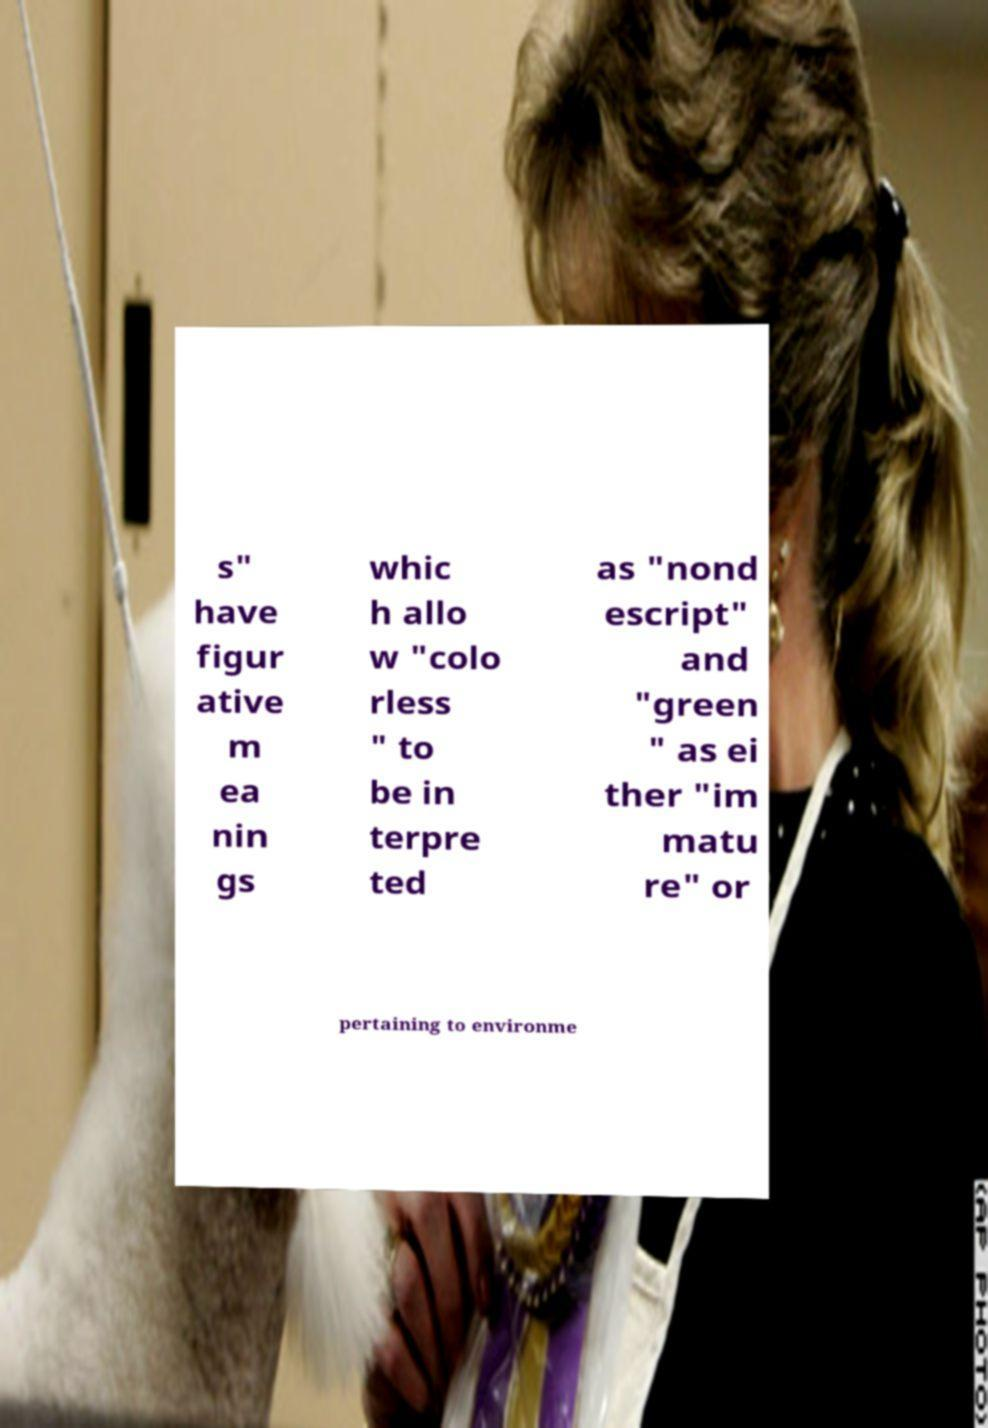What messages or text are displayed in this image? I need them in a readable, typed format. s" have figur ative m ea nin gs whic h allo w "colo rless " to be in terpre ted as "nond escript" and "green " as ei ther "im matu re" or pertaining to environme 